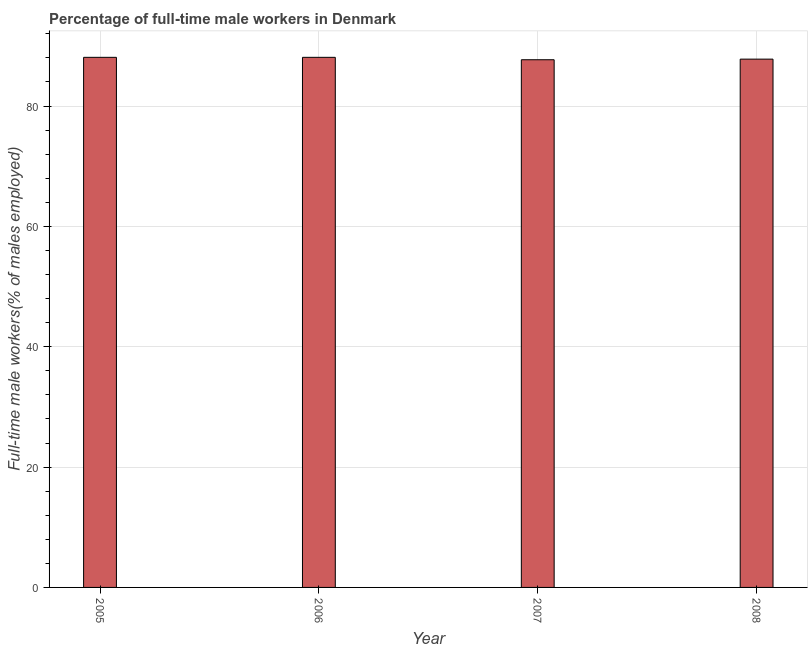Does the graph contain grids?
Offer a very short reply. Yes. What is the title of the graph?
Your answer should be compact. Percentage of full-time male workers in Denmark. What is the label or title of the Y-axis?
Ensure brevity in your answer.  Full-time male workers(% of males employed). What is the percentage of full-time male workers in 2007?
Offer a very short reply. 87.7. Across all years, what is the maximum percentage of full-time male workers?
Your response must be concise. 88.1. Across all years, what is the minimum percentage of full-time male workers?
Provide a succinct answer. 87.7. In which year was the percentage of full-time male workers maximum?
Give a very brief answer. 2005. In which year was the percentage of full-time male workers minimum?
Offer a very short reply. 2007. What is the sum of the percentage of full-time male workers?
Give a very brief answer. 351.7. What is the average percentage of full-time male workers per year?
Provide a short and direct response. 87.92. What is the median percentage of full-time male workers?
Ensure brevity in your answer.  87.95. In how many years, is the percentage of full-time male workers greater than 28 %?
Your answer should be compact. 4. Do a majority of the years between 2007 and 2005 (inclusive) have percentage of full-time male workers greater than 88 %?
Give a very brief answer. Yes. What is the ratio of the percentage of full-time male workers in 2007 to that in 2008?
Keep it short and to the point. 1. Is the difference between the percentage of full-time male workers in 2007 and 2008 greater than the difference between any two years?
Your answer should be very brief. No. What is the difference between the highest and the second highest percentage of full-time male workers?
Ensure brevity in your answer.  0. How many bars are there?
Provide a succinct answer. 4. Are all the bars in the graph horizontal?
Keep it short and to the point. No. What is the Full-time male workers(% of males employed) of 2005?
Give a very brief answer. 88.1. What is the Full-time male workers(% of males employed) in 2006?
Make the answer very short. 88.1. What is the Full-time male workers(% of males employed) of 2007?
Provide a short and direct response. 87.7. What is the Full-time male workers(% of males employed) of 2008?
Provide a short and direct response. 87.8. What is the difference between the Full-time male workers(% of males employed) in 2005 and 2007?
Offer a very short reply. 0.4. What is the difference between the Full-time male workers(% of males employed) in 2006 and 2008?
Offer a terse response. 0.3. What is the difference between the Full-time male workers(% of males employed) in 2007 and 2008?
Your response must be concise. -0.1. What is the ratio of the Full-time male workers(% of males employed) in 2005 to that in 2006?
Ensure brevity in your answer.  1. What is the ratio of the Full-time male workers(% of males employed) in 2005 to that in 2007?
Offer a very short reply. 1. What is the ratio of the Full-time male workers(% of males employed) in 2006 to that in 2007?
Provide a succinct answer. 1. 